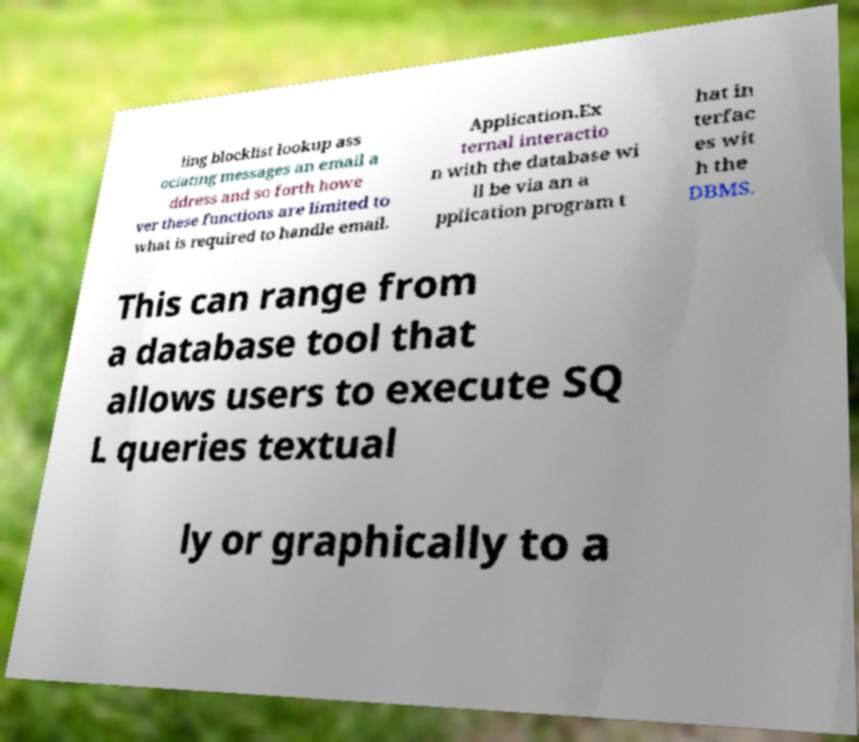What messages or text are displayed in this image? I need them in a readable, typed format. ling blocklist lookup ass ociating messages an email a ddress and so forth howe ver these functions are limited to what is required to handle email. Application.Ex ternal interactio n with the database wi ll be via an a pplication program t hat in terfac es wit h the DBMS. This can range from a database tool that allows users to execute SQ L queries textual ly or graphically to a 